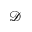Convert formula to latex. <formula><loc_0><loc_0><loc_500><loc_500>\mathcal { D }</formula> 